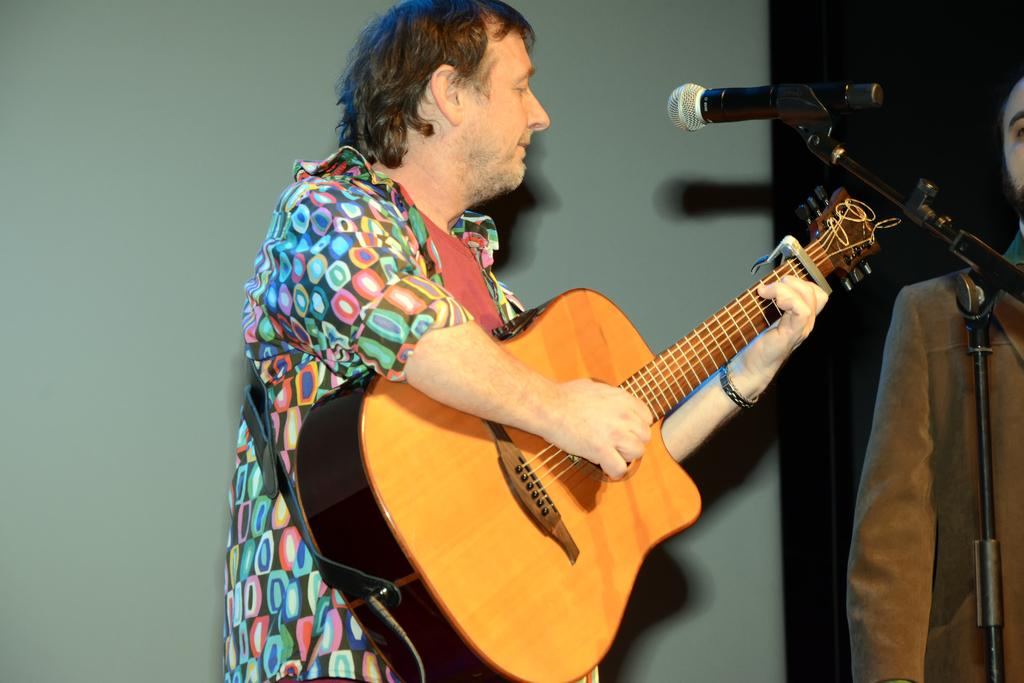How many people are in the image? There are two men in the image. What is one of the men holding? One of the men is holding a guitar. What is in front of the man holding the guitar? There is a microphone in front of the man holding the guitar. What can be seen in the background of the image? There is a wall in the background of the image. How many ladybugs are crawling on the guitar in the image? There are no ladybugs present in the image, so it is not possible to determine how many there might be on the guitar. 